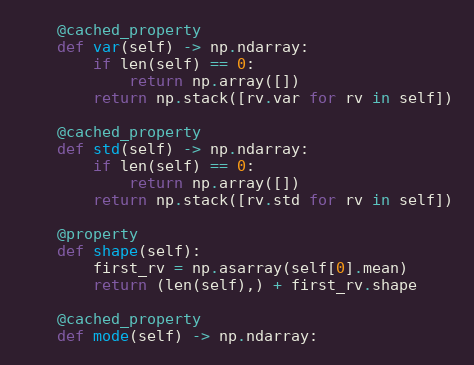Convert code to text. <code><loc_0><loc_0><loc_500><loc_500><_Python_>
    @cached_property
    def var(self) -> np.ndarray:
        if len(self) == 0:
            return np.array([])
        return np.stack([rv.var for rv in self])

    @cached_property
    def std(self) -> np.ndarray:
        if len(self) == 0:
            return np.array([])
        return np.stack([rv.std for rv in self])

    @property
    def shape(self):
        first_rv = np.asarray(self[0].mean)
        return (len(self),) + first_rv.shape

    @cached_property
    def mode(self) -> np.ndarray:</code> 